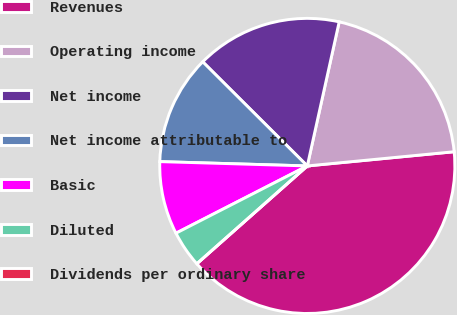Convert chart. <chart><loc_0><loc_0><loc_500><loc_500><pie_chart><fcel>Revenues<fcel>Operating income<fcel>Net income<fcel>Net income attributable to<fcel>Basic<fcel>Diluted<fcel>Dividends per ordinary share<nl><fcel>40.0%<fcel>20.0%<fcel>16.0%<fcel>12.0%<fcel>8.0%<fcel>4.0%<fcel>0.0%<nl></chart> 